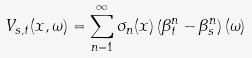Convert formula to latex. <formula><loc_0><loc_0><loc_500><loc_500>V _ { s , t } ( x , \omega ) = \sum _ { n = 1 } ^ { \infty } \sigma _ { n } ( x ) \left ( \beta ^ { n } _ { t } - \beta ^ { n } _ { s } \right ) ( \omega )</formula> 